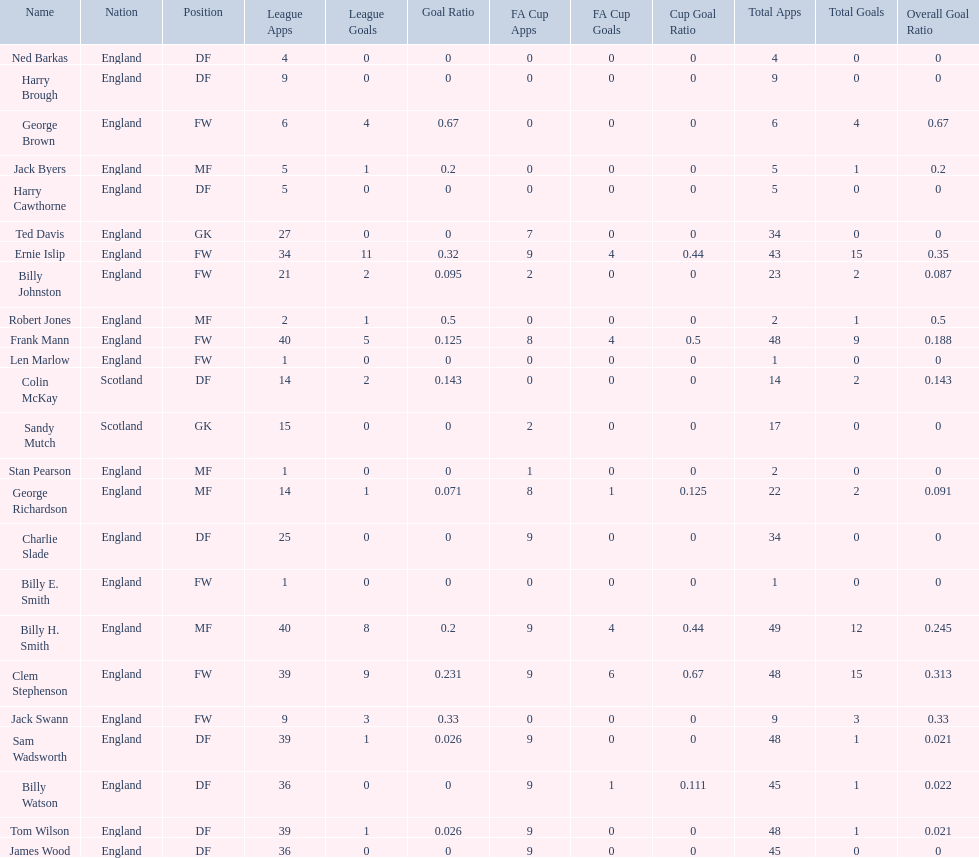What is the last name listed on this chart? James Wood. 